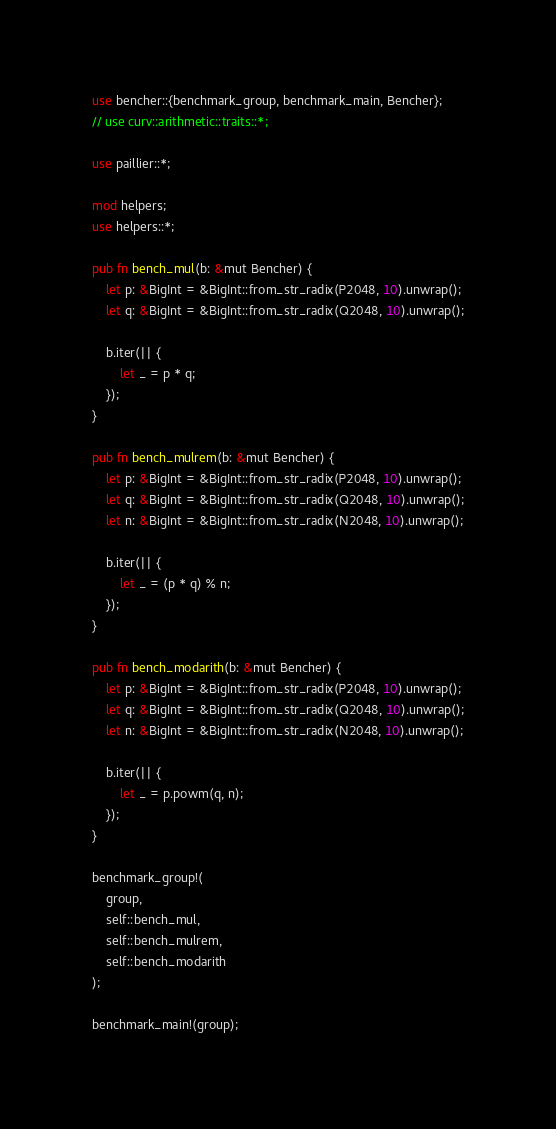Convert code to text. <code><loc_0><loc_0><loc_500><loc_500><_Rust_>use bencher::{benchmark_group, benchmark_main, Bencher};
// use curv::arithmetic::traits::*;

use paillier::*;

mod helpers;
use helpers::*;

pub fn bench_mul(b: &mut Bencher) {
    let p: &BigInt = &BigInt::from_str_radix(P2048, 10).unwrap();
    let q: &BigInt = &BigInt::from_str_radix(Q2048, 10).unwrap();

    b.iter(|| {
        let _ = p * q;
    });
}

pub fn bench_mulrem(b: &mut Bencher) {
    let p: &BigInt = &BigInt::from_str_radix(P2048, 10).unwrap();
    let q: &BigInt = &BigInt::from_str_radix(Q2048, 10).unwrap();
    let n: &BigInt = &BigInt::from_str_radix(N2048, 10).unwrap();

    b.iter(|| {
        let _ = (p * q) % n;
    });
}

pub fn bench_modarith(b: &mut Bencher) {
    let p: &BigInt = &BigInt::from_str_radix(P2048, 10).unwrap();
    let q: &BigInt = &BigInt::from_str_radix(Q2048, 10).unwrap();
    let n: &BigInt = &BigInt::from_str_radix(N2048, 10).unwrap();

    b.iter(|| {
        let _ = p.powm(q, n);
    });
}

benchmark_group!(
    group,
    self::bench_mul,
    self::bench_mulrem,
    self::bench_modarith
);

benchmark_main!(group);
</code> 